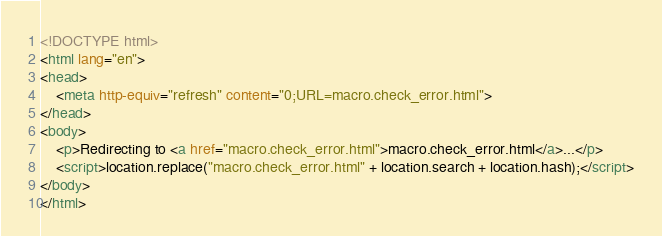Convert code to text. <code><loc_0><loc_0><loc_500><loc_500><_HTML_><!DOCTYPE html>
<html lang="en">
<head>
    <meta http-equiv="refresh" content="0;URL=macro.check_error.html">
</head>
<body>
    <p>Redirecting to <a href="macro.check_error.html">macro.check_error.html</a>...</p>
    <script>location.replace("macro.check_error.html" + location.search + location.hash);</script>
</body>
</html></code> 